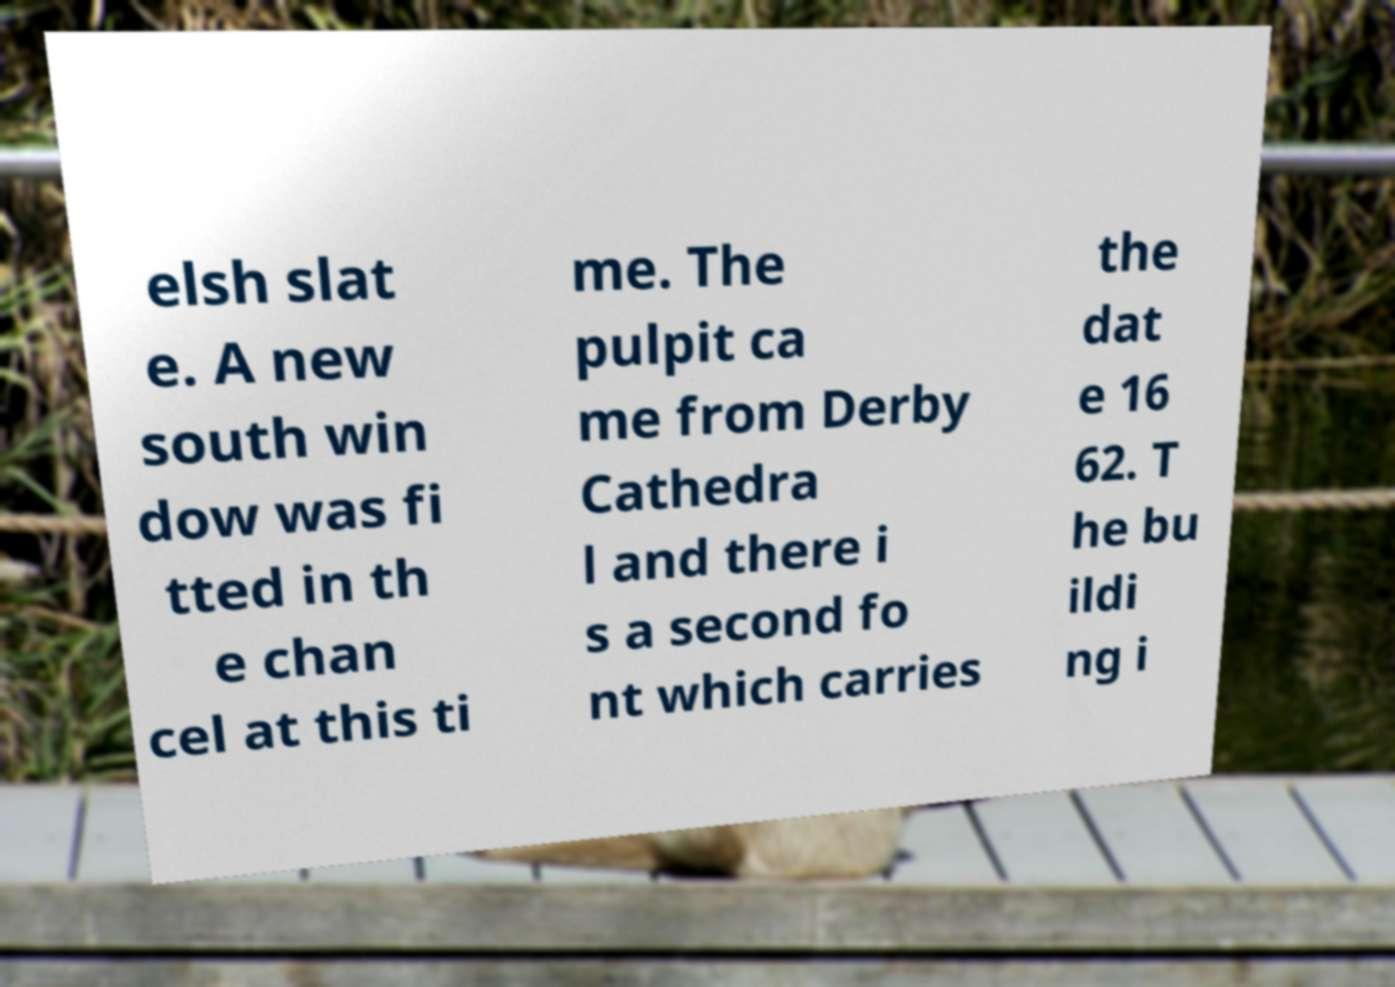Please identify and transcribe the text found in this image. elsh slat e. A new south win dow was fi tted in th e chan cel at this ti me. The pulpit ca me from Derby Cathedra l and there i s a second fo nt which carries the dat e 16 62. T he bu ildi ng i 